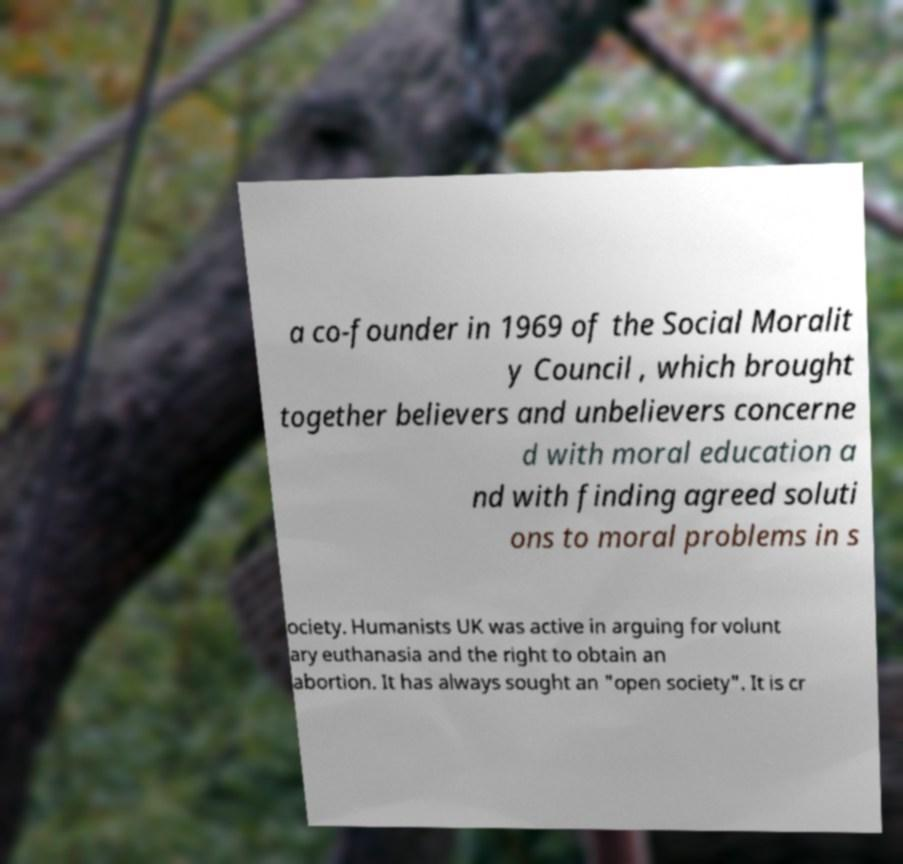Please read and relay the text visible in this image. What does it say? a co-founder in 1969 of the Social Moralit y Council , which brought together believers and unbelievers concerne d with moral education a nd with finding agreed soluti ons to moral problems in s ociety. Humanists UK was active in arguing for volunt ary euthanasia and the right to obtain an abortion. It has always sought an "open society". It is cr 